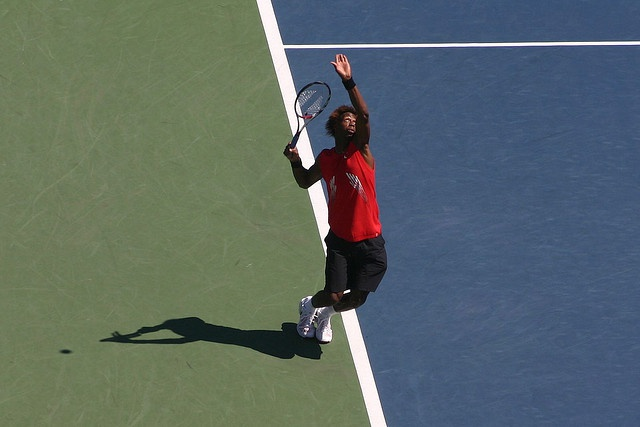Describe the objects in this image and their specific colors. I can see people in olive, black, maroon, brown, and gray tones and tennis racket in olive, gray, black, blue, and white tones in this image. 